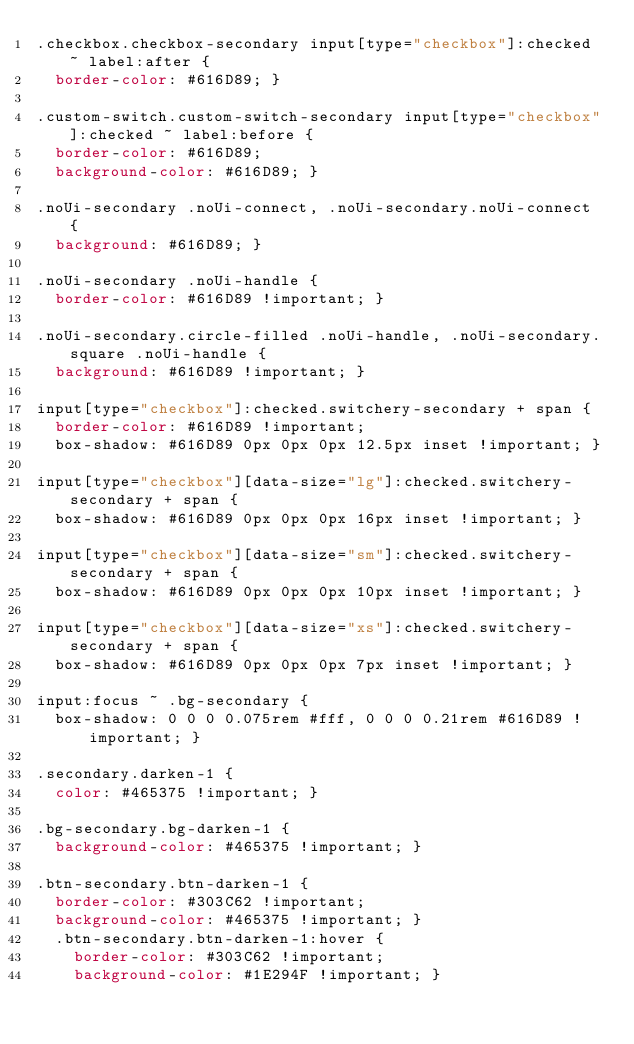Convert code to text. <code><loc_0><loc_0><loc_500><loc_500><_CSS_>.checkbox.checkbox-secondary input[type="checkbox"]:checked ~ label:after {
  border-color: #616D89; }

.custom-switch.custom-switch-secondary input[type="checkbox"]:checked ~ label:before {
  border-color: #616D89;
  background-color: #616D89; }

.noUi-secondary .noUi-connect, .noUi-secondary.noUi-connect {
  background: #616D89; }

.noUi-secondary .noUi-handle {
  border-color: #616D89 !important; }

.noUi-secondary.circle-filled .noUi-handle, .noUi-secondary.square .noUi-handle {
  background: #616D89 !important; }

input[type="checkbox"]:checked.switchery-secondary + span {
  border-color: #616D89 !important;
  box-shadow: #616D89 0px 0px 0px 12.5px inset !important; }

input[type="checkbox"][data-size="lg"]:checked.switchery-secondary + span {
  box-shadow: #616D89 0px 0px 0px 16px inset !important; }

input[type="checkbox"][data-size="sm"]:checked.switchery-secondary + span {
  box-shadow: #616D89 0px 0px 0px 10px inset !important; }

input[type="checkbox"][data-size="xs"]:checked.switchery-secondary + span {
  box-shadow: #616D89 0px 0px 0px 7px inset !important; }

input:focus ~ .bg-secondary {
  box-shadow: 0 0 0 0.075rem #fff, 0 0 0 0.21rem #616D89 !important; }

.secondary.darken-1 {
  color: #465375 !important; }

.bg-secondary.bg-darken-1 {
  background-color: #465375 !important; }

.btn-secondary.btn-darken-1 {
  border-color: #303C62 !important;
  background-color: #465375 !important; }
  .btn-secondary.btn-darken-1:hover {
    border-color: #303C62 !important;
    background-color: #1E294F !important; }</code> 